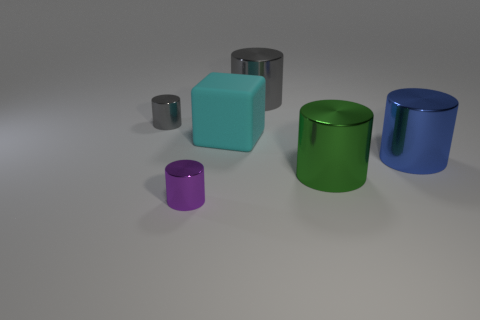How many small purple cylinders are behind the gray metal thing in front of the large cylinder that is behind the tiny gray metal cylinder? Upon carefully examining the image, there are no small purple cylinders located behind the gray object that appears to be a cubic metal block situated in front of the large green cylinder and behind the tiny gray metal cylinder. 